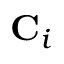Convert formula to latex. <formula><loc_0><loc_0><loc_500><loc_500>C _ { i }</formula> 